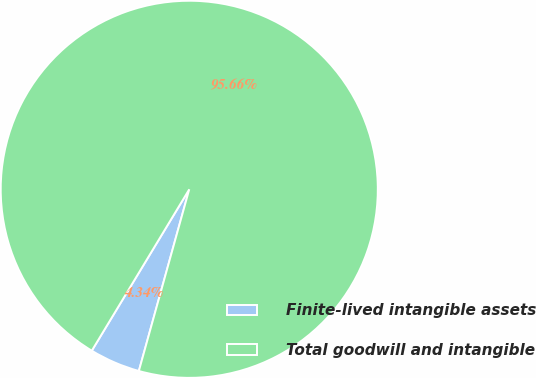Convert chart to OTSL. <chart><loc_0><loc_0><loc_500><loc_500><pie_chart><fcel>Finite-lived intangible assets<fcel>Total goodwill and intangible<nl><fcel>4.34%<fcel>95.66%<nl></chart> 